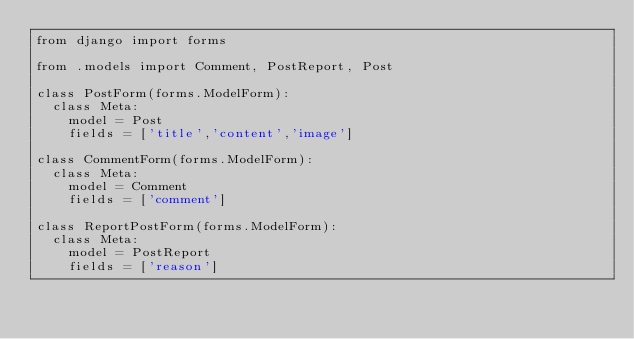Convert code to text. <code><loc_0><loc_0><loc_500><loc_500><_Python_>from django import forms

from .models import Comment, PostReport, Post

class PostForm(forms.ModelForm):
	class Meta:
		model = Post
		fields = ['title','content','image']

class CommentForm(forms.ModelForm):
	class Meta:
		model = Comment
		fields = ['comment']

class ReportPostForm(forms.ModelForm):
	class Meta:
		model = PostReport
		fields = ['reason']</code> 